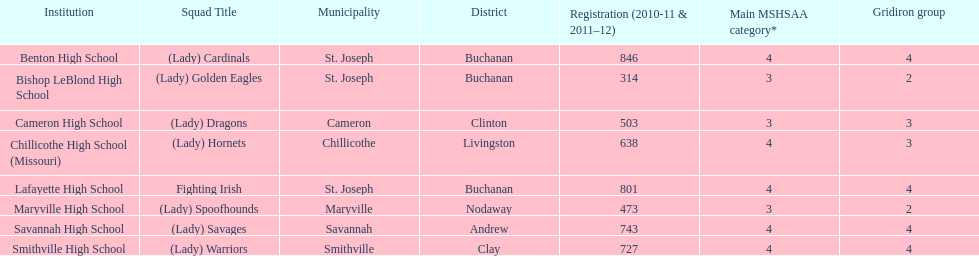Which school has the least amount of student enrollment between 2010-2011 and 2011-2012? Bishop LeBlond High School. 